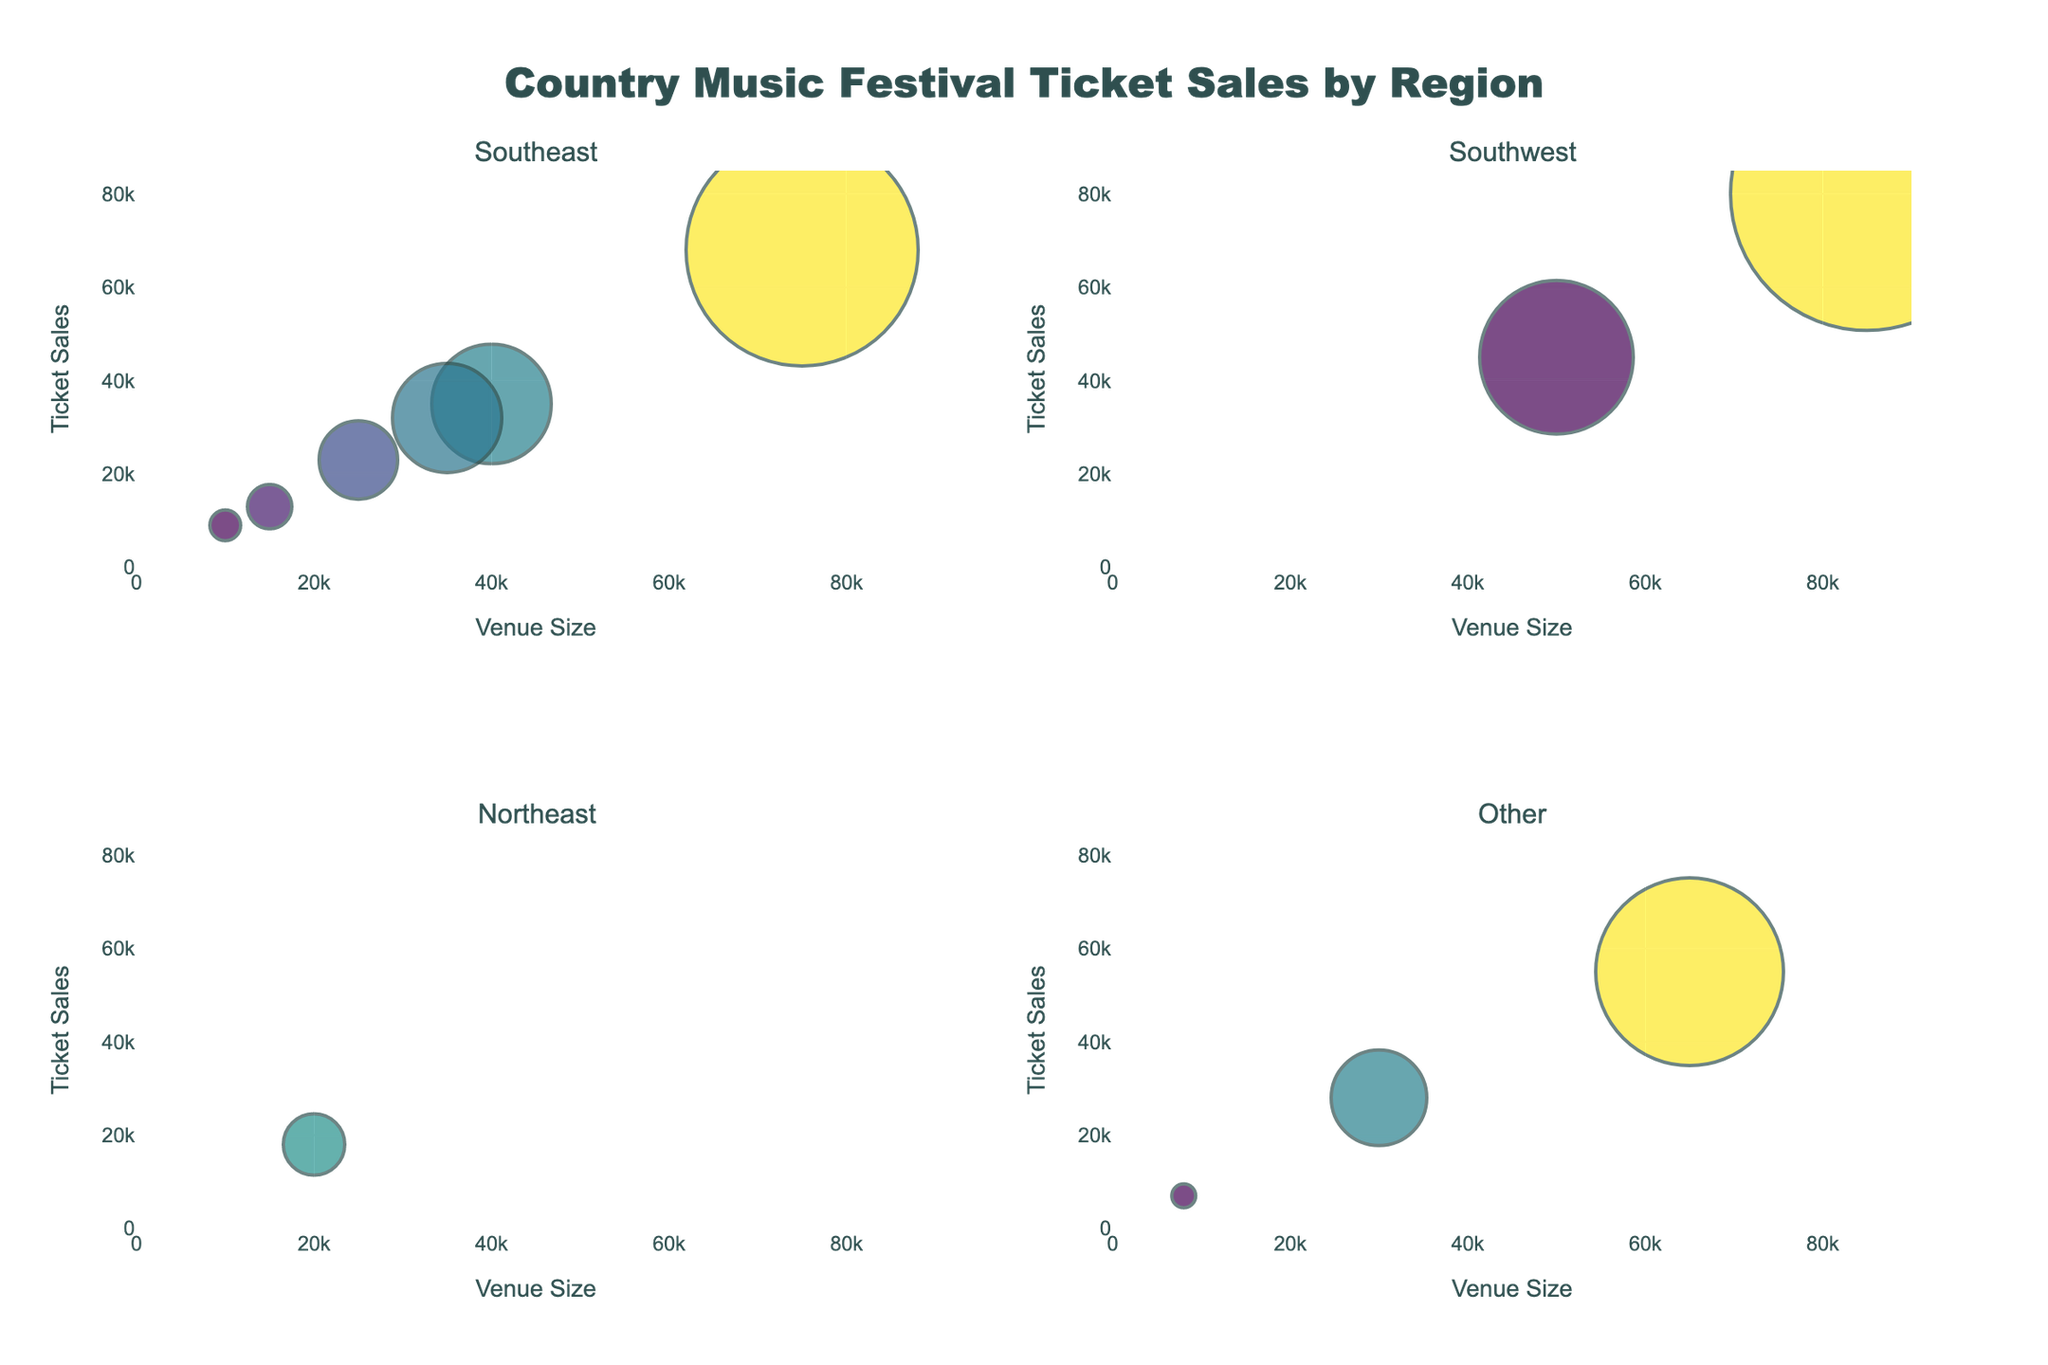What is the title of the figure? The figure has a title at the top center, which describes what the plot is about. The title is "Country Music Festival Ticket Sales by Region".
Answer: Country Music Festival Ticket Sales by Region How many festivals are displayed in the Southeast region subplot? The Southeast region is one of the subplots. By observing this subplot, we can count the number of data points (bubbles) representing festivals.
Answer: 6 Which festival in the Southwest region has the highest ticket sales? The Southwest region has its own subplot. By examining the bubbles in this region, we can compare their sizes and ticket sales. The largest bubble (highest ticket sales) is for the "Stagecoach Festival".
Answer: Stagecoach Festival What is the range of ticket sales displayed on the y-axis? The y-axis represents ticket sales for all subplots. Reading the axis labels, the range is from 0 to 85,000 ticket sales.
Answer: 0 to 85,000 Are there more festivals with a venue size above 50,000 or below 50,000? To answer this, we count the data points with a venue size above and below 50,000 across all subplots. There are 3 above and 9 below.
Answer: Below 50,000 Which region's subplot contains the festival with the smallest venue size? By examining all the subplots, we find the smallest venue size (8,000) in the "Other" region for the "ROMP Festival".
Answer: Other How do the ticket sales for "CMA Music Festival" and "Bonnaroo Music Festival" compare? We locate these two festivals in the subplots. "CMA Music Festival" has 68,000 ticket sales and "Bonnaroo Music Festival" has 55,000, hence CMA Music Festival has higher sales.
Answer: CMA Music Festival has higher sales What is the average venue size for festivals in the Northeast region? The Northeast region has only one festival ("Cornstock Folk Festival") with a venue size of 20,000. Therefore, the average venue size is simply 20,000.
Answer: 20,000 Does any festival in the Southeast region have ticket sales above 50,000? Checking the Southeast subplot, we see none of the bubbles have ticket sales exceeding 50,000, as their sizes are smaller.
Answer: No Which festival has the largest bubble size and in which region is it located? The largest bubble size correlates with the highest ticket sales. "Stagecoach Festival" in the Southwest region has the largest bubble size.
Answer: Stagecoach Festival in Southwest 